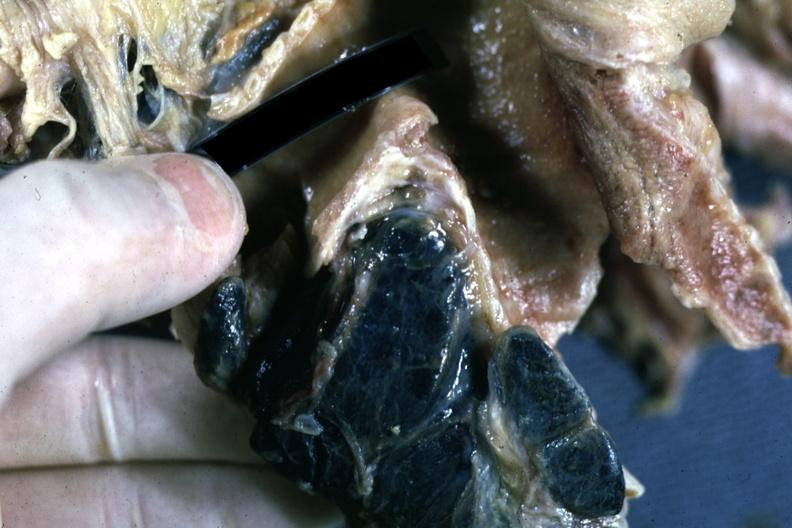re pagets disease filled with black pigment?
Answer the question using a single word or phrase. No 